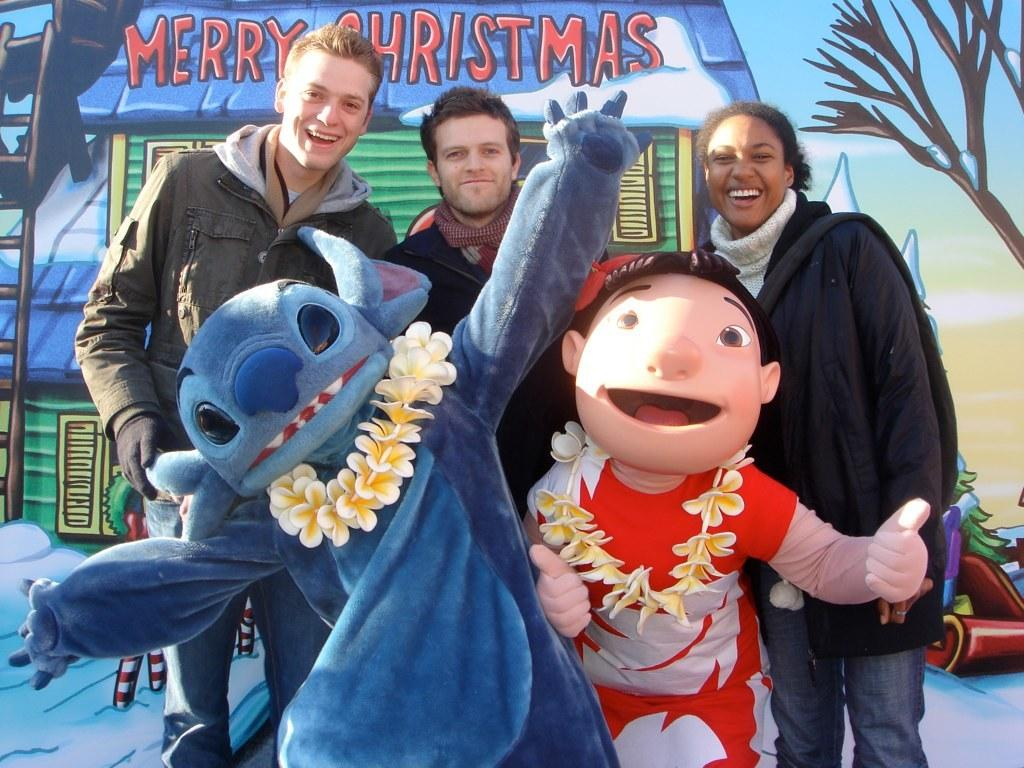How many people are in the image? There are persons in the image, but the exact number is not specified. What else can be seen in the image besides the persons? There are toys and an object visible in the image. What is present on the wall in the background of the image? There is a wall with paintings in the background of the image. What type of rod is being used by the government in the image? There is no mention of a rod or the government in the image, so this question cannot be answered. 